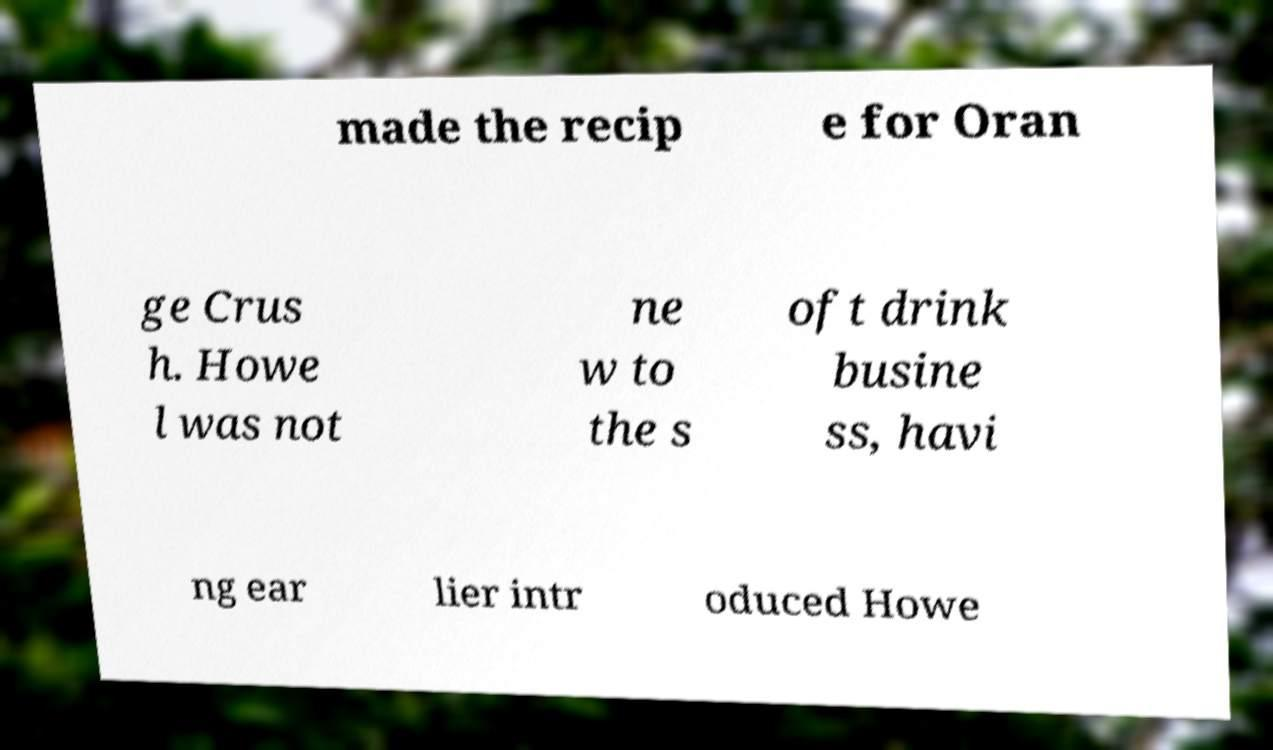Please identify and transcribe the text found in this image. made the recip e for Oran ge Crus h. Howe l was not ne w to the s oft drink busine ss, havi ng ear lier intr oduced Howe 